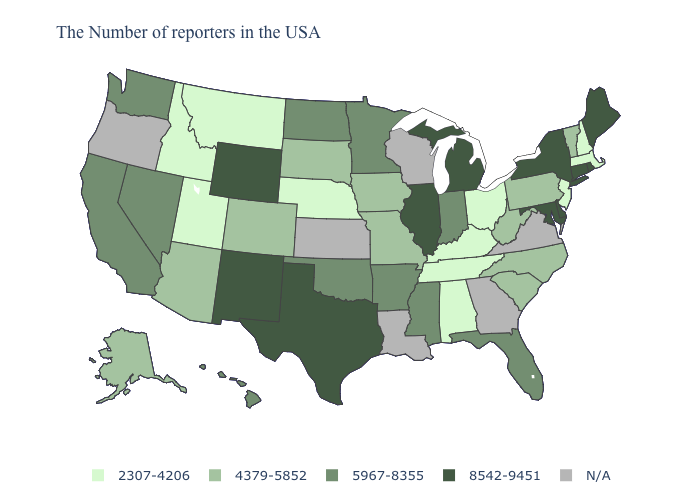Among the states that border Delaware , does Maryland have the highest value?
Quick response, please. Yes. How many symbols are there in the legend?
Answer briefly. 5. Which states have the lowest value in the USA?
Keep it brief. Massachusetts, New Hampshire, New Jersey, Ohio, Kentucky, Alabama, Tennessee, Nebraska, Utah, Montana, Idaho. Name the states that have a value in the range 4379-5852?
Concise answer only. Vermont, Pennsylvania, North Carolina, South Carolina, West Virginia, Missouri, Iowa, South Dakota, Colorado, Arizona, Alaska. Which states have the highest value in the USA?
Write a very short answer. Maine, Rhode Island, Connecticut, New York, Delaware, Maryland, Michigan, Illinois, Texas, Wyoming, New Mexico. What is the lowest value in states that border Wyoming?
Be succinct. 2307-4206. Name the states that have a value in the range 8542-9451?
Be succinct. Maine, Rhode Island, Connecticut, New York, Delaware, Maryland, Michigan, Illinois, Texas, Wyoming, New Mexico. What is the highest value in states that border Vermont?
Short answer required. 8542-9451. Which states have the lowest value in the South?
Keep it brief. Kentucky, Alabama, Tennessee. What is the value of Texas?
Quick response, please. 8542-9451. Among the states that border Vermont , which have the highest value?
Answer briefly. New York. What is the lowest value in the USA?
Keep it brief. 2307-4206. Name the states that have a value in the range 4379-5852?
Answer briefly. Vermont, Pennsylvania, North Carolina, South Carolina, West Virginia, Missouri, Iowa, South Dakota, Colorado, Arizona, Alaska. What is the value of Wyoming?
Keep it brief. 8542-9451. Name the states that have a value in the range 2307-4206?
Quick response, please. Massachusetts, New Hampshire, New Jersey, Ohio, Kentucky, Alabama, Tennessee, Nebraska, Utah, Montana, Idaho. 